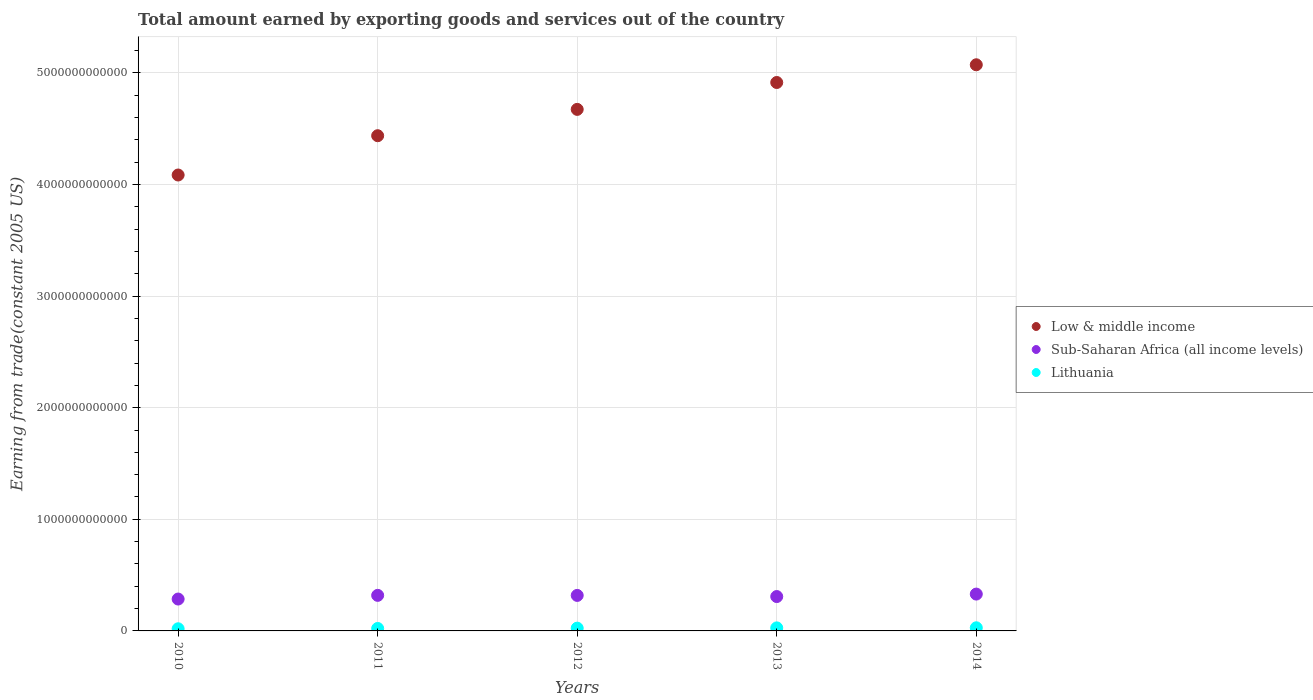Is the number of dotlines equal to the number of legend labels?
Ensure brevity in your answer.  Yes. What is the total amount earned by exporting goods and services in Low & middle income in 2010?
Ensure brevity in your answer.  4.08e+12. Across all years, what is the maximum total amount earned by exporting goods and services in Lithuania?
Keep it short and to the point. 2.80e+1. Across all years, what is the minimum total amount earned by exporting goods and services in Low & middle income?
Offer a terse response. 4.08e+12. In which year was the total amount earned by exporting goods and services in Lithuania minimum?
Offer a terse response. 2010. What is the total total amount earned by exporting goods and services in Low & middle income in the graph?
Keep it short and to the point. 2.32e+13. What is the difference between the total amount earned by exporting goods and services in Low & middle income in 2011 and that in 2012?
Ensure brevity in your answer.  -2.36e+11. What is the difference between the total amount earned by exporting goods and services in Lithuania in 2013 and the total amount earned by exporting goods and services in Low & middle income in 2012?
Make the answer very short. -4.65e+12. What is the average total amount earned by exporting goods and services in Low & middle income per year?
Offer a terse response. 4.64e+12. In the year 2012, what is the difference between the total amount earned by exporting goods and services in Low & middle income and total amount earned by exporting goods and services in Sub-Saharan Africa (all income levels)?
Provide a short and direct response. 4.35e+12. What is the ratio of the total amount earned by exporting goods and services in Sub-Saharan Africa (all income levels) in 2010 to that in 2014?
Offer a very short reply. 0.87. Is the difference between the total amount earned by exporting goods and services in Low & middle income in 2012 and 2013 greater than the difference between the total amount earned by exporting goods and services in Sub-Saharan Africa (all income levels) in 2012 and 2013?
Your response must be concise. No. What is the difference between the highest and the second highest total amount earned by exporting goods and services in Low & middle income?
Your answer should be compact. 1.59e+11. What is the difference between the highest and the lowest total amount earned by exporting goods and services in Lithuania?
Provide a succinct answer. 8.79e+09. In how many years, is the total amount earned by exporting goods and services in Low & middle income greater than the average total amount earned by exporting goods and services in Low & middle income taken over all years?
Offer a very short reply. 3. Is the sum of the total amount earned by exporting goods and services in Low & middle income in 2010 and 2011 greater than the maximum total amount earned by exporting goods and services in Sub-Saharan Africa (all income levels) across all years?
Ensure brevity in your answer.  Yes. Is it the case that in every year, the sum of the total amount earned by exporting goods and services in Lithuania and total amount earned by exporting goods and services in Sub-Saharan Africa (all income levels)  is greater than the total amount earned by exporting goods and services in Low & middle income?
Give a very brief answer. No. Does the total amount earned by exporting goods and services in Lithuania monotonically increase over the years?
Make the answer very short. Yes. Is the total amount earned by exporting goods and services in Low & middle income strictly less than the total amount earned by exporting goods and services in Lithuania over the years?
Keep it short and to the point. No. How many years are there in the graph?
Provide a short and direct response. 5. What is the difference between two consecutive major ticks on the Y-axis?
Provide a succinct answer. 1.00e+12. Does the graph contain any zero values?
Make the answer very short. No. Where does the legend appear in the graph?
Offer a very short reply. Center right. What is the title of the graph?
Your answer should be compact. Total amount earned by exporting goods and services out of the country. What is the label or title of the Y-axis?
Provide a succinct answer. Earning from trade(constant 2005 US). What is the Earning from trade(constant 2005 US) of Low & middle income in 2010?
Make the answer very short. 4.08e+12. What is the Earning from trade(constant 2005 US) of Sub-Saharan Africa (all income levels) in 2010?
Give a very brief answer. 2.86e+11. What is the Earning from trade(constant 2005 US) in Lithuania in 2010?
Offer a terse response. 1.92e+1. What is the Earning from trade(constant 2005 US) of Low & middle income in 2011?
Provide a succinct answer. 4.44e+12. What is the Earning from trade(constant 2005 US) of Sub-Saharan Africa (all income levels) in 2011?
Your response must be concise. 3.19e+11. What is the Earning from trade(constant 2005 US) of Lithuania in 2011?
Offer a terse response. 2.21e+1. What is the Earning from trade(constant 2005 US) of Low & middle income in 2012?
Provide a succinct answer. 4.67e+12. What is the Earning from trade(constant 2005 US) of Sub-Saharan Africa (all income levels) in 2012?
Make the answer very short. 3.18e+11. What is the Earning from trade(constant 2005 US) in Lithuania in 2012?
Provide a short and direct response. 2.48e+1. What is the Earning from trade(constant 2005 US) of Low & middle income in 2013?
Make the answer very short. 4.91e+12. What is the Earning from trade(constant 2005 US) in Sub-Saharan Africa (all income levels) in 2013?
Provide a succinct answer. 3.08e+11. What is the Earning from trade(constant 2005 US) in Lithuania in 2013?
Provide a short and direct response. 2.72e+1. What is the Earning from trade(constant 2005 US) of Low & middle income in 2014?
Give a very brief answer. 5.07e+12. What is the Earning from trade(constant 2005 US) in Sub-Saharan Africa (all income levels) in 2014?
Provide a short and direct response. 3.30e+11. What is the Earning from trade(constant 2005 US) of Lithuania in 2014?
Provide a short and direct response. 2.80e+1. Across all years, what is the maximum Earning from trade(constant 2005 US) in Low & middle income?
Provide a short and direct response. 5.07e+12. Across all years, what is the maximum Earning from trade(constant 2005 US) in Sub-Saharan Africa (all income levels)?
Provide a short and direct response. 3.30e+11. Across all years, what is the maximum Earning from trade(constant 2005 US) in Lithuania?
Make the answer very short. 2.80e+1. Across all years, what is the minimum Earning from trade(constant 2005 US) of Low & middle income?
Ensure brevity in your answer.  4.08e+12. Across all years, what is the minimum Earning from trade(constant 2005 US) of Sub-Saharan Africa (all income levels)?
Offer a very short reply. 2.86e+11. Across all years, what is the minimum Earning from trade(constant 2005 US) of Lithuania?
Offer a very short reply. 1.92e+1. What is the total Earning from trade(constant 2005 US) of Low & middle income in the graph?
Your response must be concise. 2.32e+13. What is the total Earning from trade(constant 2005 US) of Sub-Saharan Africa (all income levels) in the graph?
Make the answer very short. 1.56e+12. What is the total Earning from trade(constant 2005 US) in Lithuania in the graph?
Make the answer very short. 1.21e+11. What is the difference between the Earning from trade(constant 2005 US) of Low & middle income in 2010 and that in 2011?
Ensure brevity in your answer.  -3.52e+11. What is the difference between the Earning from trade(constant 2005 US) of Sub-Saharan Africa (all income levels) in 2010 and that in 2011?
Provide a short and direct response. -3.30e+1. What is the difference between the Earning from trade(constant 2005 US) in Lithuania in 2010 and that in 2011?
Offer a terse response. -2.86e+09. What is the difference between the Earning from trade(constant 2005 US) of Low & middle income in 2010 and that in 2012?
Ensure brevity in your answer.  -5.88e+11. What is the difference between the Earning from trade(constant 2005 US) in Sub-Saharan Africa (all income levels) in 2010 and that in 2012?
Keep it short and to the point. -3.25e+1. What is the difference between the Earning from trade(constant 2005 US) in Lithuania in 2010 and that in 2012?
Ensure brevity in your answer.  -5.56e+09. What is the difference between the Earning from trade(constant 2005 US) in Low & middle income in 2010 and that in 2013?
Offer a terse response. -8.29e+11. What is the difference between the Earning from trade(constant 2005 US) of Sub-Saharan Africa (all income levels) in 2010 and that in 2013?
Your response must be concise. -2.23e+1. What is the difference between the Earning from trade(constant 2005 US) of Lithuania in 2010 and that in 2013?
Offer a very short reply. -7.96e+09. What is the difference between the Earning from trade(constant 2005 US) in Low & middle income in 2010 and that in 2014?
Ensure brevity in your answer.  -9.88e+11. What is the difference between the Earning from trade(constant 2005 US) of Sub-Saharan Africa (all income levels) in 2010 and that in 2014?
Keep it short and to the point. -4.44e+1. What is the difference between the Earning from trade(constant 2005 US) in Lithuania in 2010 and that in 2014?
Keep it short and to the point. -8.79e+09. What is the difference between the Earning from trade(constant 2005 US) of Low & middle income in 2011 and that in 2012?
Ensure brevity in your answer.  -2.36e+11. What is the difference between the Earning from trade(constant 2005 US) of Sub-Saharan Africa (all income levels) in 2011 and that in 2012?
Offer a terse response. 4.93e+08. What is the difference between the Earning from trade(constant 2005 US) of Lithuania in 2011 and that in 2012?
Your answer should be compact. -2.70e+09. What is the difference between the Earning from trade(constant 2005 US) of Low & middle income in 2011 and that in 2013?
Give a very brief answer. -4.77e+11. What is the difference between the Earning from trade(constant 2005 US) in Sub-Saharan Africa (all income levels) in 2011 and that in 2013?
Provide a succinct answer. 1.07e+1. What is the difference between the Earning from trade(constant 2005 US) in Lithuania in 2011 and that in 2013?
Keep it short and to the point. -5.09e+09. What is the difference between the Earning from trade(constant 2005 US) of Low & middle income in 2011 and that in 2014?
Ensure brevity in your answer.  -6.36e+11. What is the difference between the Earning from trade(constant 2005 US) of Sub-Saharan Africa (all income levels) in 2011 and that in 2014?
Your answer should be compact. -1.14e+1. What is the difference between the Earning from trade(constant 2005 US) of Lithuania in 2011 and that in 2014?
Your answer should be compact. -5.92e+09. What is the difference between the Earning from trade(constant 2005 US) in Low & middle income in 2012 and that in 2013?
Your answer should be very brief. -2.41e+11. What is the difference between the Earning from trade(constant 2005 US) of Sub-Saharan Africa (all income levels) in 2012 and that in 2013?
Keep it short and to the point. 1.02e+1. What is the difference between the Earning from trade(constant 2005 US) in Lithuania in 2012 and that in 2013?
Ensure brevity in your answer.  -2.39e+09. What is the difference between the Earning from trade(constant 2005 US) in Low & middle income in 2012 and that in 2014?
Make the answer very short. -4.00e+11. What is the difference between the Earning from trade(constant 2005 US) in Sub-Saharan Africa (all income levels) in 2012 and that in 2014?
Provide a short and direct response. -1.19e+1. What is the difference between the Earning from trade(constant 2005 US) in Lithuania in 2012 and that in 2014?
Your response must be concise. -3.22e+09. What is the difference between the Earning from trade(constant 2005 US) in Low & middle income in 2013 and that in 2014?
Make the answer very short. -1.59e+11. What is the difference between the Earning from trade(constant 2005 US) in Sub-Saharan Africa (all income levels) in 2013 and that in 2014?
Ensure brevity in your answer.  -2.21e+1. What is the difference between the Earning from trade(constant 2005 US) in Lithuania in 2013 and that in 2014?
Provide a short and direct response. -8.29e+08. What is the difference between the Earning from trade(constant 2005 US) of Low & middle income in 2010 and the Earning from trade(constant 2005 US) of Sub-Saharan Africa (all income levels) in 2011?
Your response must be concise. 3.77e+12. What is the difference between the Earning from trade(constant 2005 US) in Low & middle income in 2010 and the Earning from trade(constant 2005 US) in Lithuania in 2011?
Give a very brief answer. 4.06e+12. What is the difference between the Earning from trade(constant 2005 US) in Sub-Saharan Africa (all income levels) in 2010 and the Earning from trade(constant 2005 US) in Lithuania in 2011?
Your response must be concise. 2.64e+11. What is the difference between the Earning from trade(constant 2005 US) in Low & middle income in 2010 and the Earning from trade(constant 2005 US) in Sub-Saharan Africa (all income levels) in 2012?
Keep it short and to the point. 3.77e+12. What is the difference between the Earning from trade(constant 2005 US) in Low & middle income in 2010 and the Earning from trade(constant 2005 US) in Lithuania in 2012?
Make the answer very short. 4.06e+12. What is the difference between the Earning from trade(constant 2005 US) in Sub-Saharan Africa (all income levels) in 2010 and the Earning from trade(constant 2005 US) in Lithuania in 2012?
Make the answer very short. 2.61e+11. What is the difference between the Earning from trade(constant 2005 US) of Low & middle income in 2010 and the Earning from trade(constant 2005 US) of Sub-Saharan Africa (all income levels) in 2013?
Make the answer very short. 3.78e+12. What is the difference between the Earning from trade(constant 2005 US) in Low & middle income in 2010 and the Earning from trade(constant 2005 US) in Lithuania in 2013?
Your answer should be very brief. 4.06e+12. What is the difference between the Earning from trade(constant 2005 US) in Sub-Saharan Africa (all income levels) in 2010 and the Earning from trade(constant 2005 US) in Lithuania in 2013?
Offer a very short reply. 2.58e+11. What is the difference between the Earning from trade(constant 2005 US) in Low & middle income in 2010 and the Earning from trade(constant 2005 US) in Sub-Saharan Africa (all income levels) in 2014?
Make the answer very short. 3.75e+12. What is the difference between the Earning from trade(constant 2005 US) of Low & middle income in 2010 and the Earning from trade(constant 2005 US) of Lithuania in 2014?
Ensure brevity in your answer.  4.06e+12. What is the difference between the Earning from trade(constant 2005 US) in Sub-Saharan Africa (all income levels) in 2010 and the Earning from trade(constant 2005 US) in Lithuania in 2014?
Provide a succinct answer. 2.58e+11. What is the difference between the Earning from trade(constant 2005 US) of Low & middle income in 2011 and the Earning from trade(constant 2005 US) of Sub-Saharan Africa (all income levels) in 2012?
Keep it short and to the point. 4.12e+12. What is the difference between the Earning from trade(constant 2005 US) in Low & middle income in 2011 and the Earning from trade(constant 2005 US) in Lithuania in 2012?
Your response must be concise. 4.41e+12. What is the difference between the Earning from trade(constant 2005 US) of Sub-Saharan Africa (all income levels) in 2011 and the Earning from trade(constant 2005 US) of Lithuania in 2012?
Keep it short and to the point. 2.94e+11. What is the difference between the Earning from trade(constant 2005 US) of Low & middle income in 2011 and the Earning from trade(constant 2005 US) of Sub-Saharan Africa (all income levels) in 2013?
Your answer should be compact. 4.13e+12. What is the difference between the Earning from trade(constant 2005 US) of Low & middle income in 2011 and the Earning from trade(constant 2005 US) of Lithuania in 2013?
Make the answer very short. 4.41e+12. What is the difference between the Earning from trade(constant 2005 US) in Sub-Saharan Africa (all income levels) in 2011 and the Earning from trade(constant 2005 US) in Lithuania in 2013?
Keep it short and to the point. 2.91e+11. What is the difference between the Earning from trade(constant 2005 US) in Low & middle income in 2011 and the Earning from trade(constant 2005 US) in Sub-Saharan Africa (all income levels) in 2014?
Give a very brief answer. 4.11e+12. What is the difference between the Earning from trade(constant 2005 US) in Low & middle income in 2011 and the Earning from trade(constant 2005 US) in Lithuania in 2014?
Your answer should be compact. 4.41e+12. What is the difference between the Earning from trade(constant 2005 US) of Sub-Saharan Africa (all income levels) in 2011 and the Earning from trade(constant 2005 US) of Lithuania in 2014?
Make the answer very short. 2.91e+11. What is the difference between the Earning from trade(constant 2005 US) of Low & middle income in 2012 and the Earning from trade(constant 2005 US) of Sub-Saharan Africa (all income levels) in 2013?
Make the answer very short. 4.36e+12. What is the difference between the Earning from trade(constant 2005 US) in Low & middle income in 2012 and the Earning from trade(constant 2005 US) in Lithuania in 2013?
Your response must be concise. 4.65e+12. What is the difference between the Earning from trade(constant 2005 US) of Sub-Saharan Africa (all income levels) in 2012 and the Earning from trade(constant 2005 US) of Lithuania in 2013?
Make the answer very short. 2.91e+11. What is the difference between the Earning from trade(constant 2005 US) in Low & middle income in 2012 and the Earning from trade(constant 2005 US) in Sub-Saharan Africa (all income levels) in 2014?
Make the answer very short. 4.34e+12. What is the difference between the Earning from trade(constant 2005 US) of Low & middle income in 2012 and the Earning from trade(constant 2005 US) of Lithuania in 2014?
Provide a succinct answer. 4.64e+12. What is the difference between the Earning from trade(constant 2005 US) of Sub-Saharan Africa (all income levels) in 2012 and the Earning from trade(constant 2005 US) of Lithuania in 2014?
Provide a succinct answer. 2.90e+11. What is the difference between the Earning from trade(constant 2005 US) in Low & middle income in 2013 and the Earning from trade(constant 2005 US) in Sub-Saharan Africa (all income levels) in 2014?
Your answer should be very brief. 4.58e+12. What is the difference between the Earning from trade(constant 2005 US) of Low & middle income in 2013 and the Earning from trade(constant 2005 US) of Lithuania in 2014?
Offer a terse response. 4.89e+12. What is the difference between the Earning from trade(constant 2005 US) in Sub-Saharan Africa (all income levels) in 2013 and the Earning from trade(constant 2005 US) in Lithuania in 2014?
Offer a very short reply. 2.80e+11. What is the average Earning from trade(constant 2005 US) of Low & middle income per year?
Offer a very short reply. 4.64e+12. What is the average Earning from trade(constant 2005 US) of Sub-Saharan Africa (all income levels) per year?
Offer a terse response. 3.12e+11. What is the average Earning from trade(constant 2005 US) in Lithuania per year?
Offer a terse response. 2.43e+1. In the year 2010, what is the difference between the Earning from trade(constant 2005 US) of Low & middle income and Earning from trade(constant 2005 US) of Sub-Saharan Africa (all income levels)?
Make the answer very short. 3.80e+12. In the year 2010, what is the difference between the Earning from trade(constant 2005 US) in Low & middle income and Earning from trade(constant 2005 US) in Lithuania?
Your answer should be compact. 4.07e+12. In the year 2010, what is the difference between the Earning from trade(constant 2005 US) in Sub-Saharan Africa (all income levels) and Earning from trade(constant 2005 US) in Lithuania?
Provide a succinct answer. 2.66e+11. In the year 2011, what is the difference between the Earning from trade(constant 2005 US) of Low & middle income and Earning from trade(constant 2005 US) of Sub-Saharan Africa (all income levels)?
Keep it short and to the point. 4.12e+12. In the year 2011, what is the difference between the Earning from trade(constant 2005 US) in Low & middle income and Earning from trade(constant 2005 US) in Lithuania?
Your answer should be very brief. 4.41e+12. In the year 2011, what is the difference between the Earning from trade(constant 2005 US) of Sub-Saharan Africa (all income levels) and Earning from trade(constant 2005 US) of Lithuania?
Give a very brief answer. 2.97e+11. In the year 2012, what is the difference between the Earning from trade(constant 2005 US) in Low & middle income and Earning from trade(constant 2005 US) in Sub-Saharan Africa (all income levels)?
Keep it short and to the point. 4.35e+12. In the year 2012, what is the difference between the Earning from trade(constant 2005 US) in Low & middle income and Earning from trade(constant 2005 US) in Lithuania?
Provide a short and direct response. 4.65e+12. In the year 2012, what is the difference between the Earning from trade(constant 2005 US) of Sub-Saharan Africa (all income levels) and Earning from trade(constant 2005 US) of Lithuania?
Your response must be concise. 2.93e+11. In the year 2013, what is the difference between the Earning from trade(constant 2005 US) in Low & middle income and Earning from trade(constant 2005 US) in Sub-Saharan Africa (all income levels)?
Provide a short and direct response. 4.61e+12. In the year 2013, what is the difference between the Earning from trade(constant 2005 US) of Low & middle income and Earning from trade(constant 2005 US) of Lithuania?
Give a very brief answer. 4.89e+12. In the year 2013, what is the difference between the Earning from trade(constant 2005 US) in Sub-Saharan Africa (all income levels) and Earning from trade(constant 2005 US) in Lithuania?
Your answer should be compact. 2.81e+11. In the year 2014, what is the difference between the Earning from trade(constant 2005 US) in Low & middle income and Earning from trade(constant 2005 US) in Sub-Saharan Africa (all income levels)?
Provide a succinct answer. 4.74e+12. In the year 2014, what is the difference between the Earning from trade(constant 2005 US) in Low & middle income and Earning from trade(constant 2005 US) in Lithuania?
Make the answer very short. 5.04e+12. In the year 2014, what is the difference between the Earning from trade(constant 2005 US) of Sub-Saharan Africa (all income levels) and Earning from trade(constant 2005 US) of Lithuania?
Offer a very short reply. 3.02e+11. What is the ratio of the Earning from trade(constant 2005 US) of Low & middle income in 2010 to that in 2011?
Your response must be concise. 0.92. What is the ratio of the Earning from trade(constant 2005 US) of Sub-Saharan Africa (all income levels) in 2010 to that in 2011?
Offer a very short reply. 0.9. What is the ratio of the Earning from trade(constant 2005 US) in Lithuania in 2010 to that in 2011?
Make the answer very short. 0.87. What is the ratio of the Earning from trade(constant 2005 US) in Low & middle income in 2010 to that in 2012?
Ensure brevity in your answer.  0.87. What is the ratio of the Earning from trade(constant 2005 US) of Sub-Saharan Africa (all income levels) in 2010 to that in 2012?
Your response must be concise. 0.9. What is the ratio of the Earning from trade(constant 2005 US) of Lithuania in 2010 to that in 2012?
Provide a succinct answer. 0.78. What is the ratio of the Earning from trade(constant 2005 US) in Low & middle income in 2010 to that in 2013?
Ensure brevity in your answer.  0.83. What is the ratio of the Earning from trade(constant 2005 US) of Sub-Saharan Africa (all income levels) in 2010 to that in 2013?
Keep it short and to the point. 0.93. What is the ratio of the Earning from trade(constant 2005 US) in Lithuania in 2010 to that in 2013?
Your answer should be compact. 0.71. What is the ratio of the Earning from trade(constant 2005 US) in Low & middle income in 2010 to that in 2014?
Keep it short and to the point. 0.81. What is the ratio of the Earning from trade(constant 2005 US) in Sub-Saharan Africa (all income levels) in 2010 to that in 2014?
Keep it short and to the point. 0.87. What is the ratio of the Earning from trade(constant 2005 US) of Lithuania in 2010 to that in 2014?
Give a very brief answer. 0.69. What is the ratio of the Earning from trade(constant 2005 US) in Low & middle income in 2011 to that in 2012?
Offer a very short reply. 0.95. What is the ratio of the Earning from trade(constant 2005 US) in Sub-Saharan Africa (all income levels) in 2011 to that in 2012?
Your response must be concise. 1. What is the ratio of the Earning from trade(constant 2005 US) of Lithuania in 2011 to that in 2012?
Make the answer very short. 0.89. What is the ratio of the Earning from trade(constant 2005 US) of Low & middle income in 2011 to that in 2013?
Ensure brevity in your answer.  0.9. What is the ratio of the Earning from trade(constant 2005 US) in Sub-Saharan Africa (all income levels) in 2011 to that in 2013?
Provide a succinct answer. 1.03. What is the ratio of the Earning from trade(constant 2005 US) of Lithuania in 2011 to that in 2013?
Offer a very short reply. 0.81. What is the ratio of the Earning from trade(constant 2005 US) in Low & middle income in 2011 to that in 2014?
Make the answer very short. 0.87. What is the ratio of the Earning from trade(constant 2005 US) of Sub-Saharan Africa (all income levels) in 2011 to that in 2014?
Make the answer very short. 0.97. What is the ratio of the Earning from trade(constant 2005 US) in Lithuania in 2011 to that in 2014?
Give a very brief answer. 0.79. What is the ratio of the Earning from trade(constant 2005 US) in Low & middle income in 2012 to that in 2013?
Offer a very short reply. 0.95. What is the ratio of the Earning from trade(constant 2005 US) of Lithuania in 2012 to that in 2013?
Your response must be concise. 0.91. What is the ratio of the Earning from trade(constant 2005 US) in Low & middle income in 2012 to that in 2014?
Make the answer very short. 0.92. What is the ratio of the Earning from trade(constant 2005 US) of Sub-Saharan Africa (all income levels) in 2012 to that in 2014?
Your answer should be compact. 0.96. What is the ratio of the Earning from trade(constant 2005 US) in Lithuania in 2012 to that in 2014?
Your answer should be compact. 0.89. What is the ratio of the Earning from trade(constant 2005 US) of Low & middle income in 2013 to that in 2014?
Provide a short and direct response. 0.97. What is the ratio of the Earning from trade(constant 2005 US) in Sub-Saharan Africa (all income levels) in 2013 to that in 2014?
Make the answer very short. 0.93. What is the ratio of the Earning from trade(constant 2005 US) in Lithuania in 2013 to that in 2014?
Offer a very short reply. 0.97. What is the difference between the highest and the second highest Earning from trade(constant 2005 US) in Low & middle income?
Your answer should be very brief. 1.59e+11. What is the difference between the highest and the second highest Earning from trade(constant 2005 US) of Sub-Saharan Africa (all income levels)?
Keep it short and to the point. 1.14e+1. What is the difference between the highest and the second highest Earning from trade(constant 2005 US) of Lithuania?
Keep it short and to the point. 8.29e+08. What is the difference between the highest and the lowest Earning from trade(constant 2005 US) of Low & middle income?
Offer a terse response. 9.88e+11. What is the difference between the highest and the lowest Earning from trade(constant 2005 US) of Sub-Saharan Africa (all income levels)?
Your response must be concise. 4.44e+1. What is the difference between the highest and the lowest Earning from trade(constant 2005 US) in Lithuania?
Ensure brevity in your answer.  8.79e+09. 